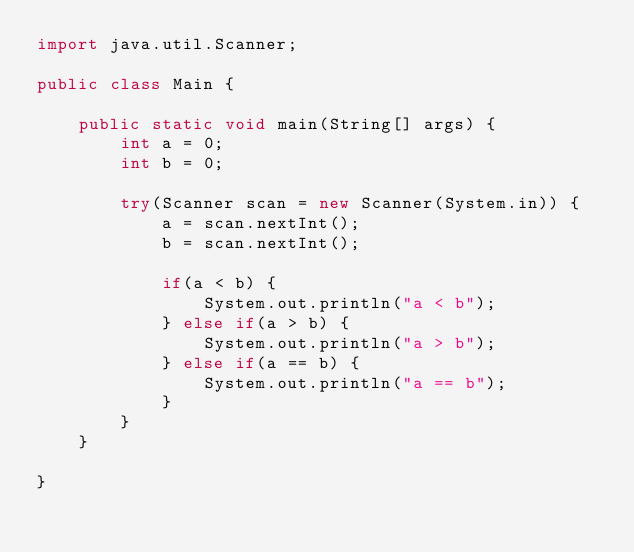Convert code to text. <code><loc_0><loc_0><loc_500><loc_500><_Java_>import java.util.Scanner;

public class Main {

	public static void main(String[] args) {
		int a = 0;
		int b = 0;

		try(Scanner scan = new Scanner(System.in)) {
			a = scan.nextInt();
			b = scan.nextInt();

			if(a < b) {
				System.out.println("a < b");
			} else if(a > b) {
				System.out.println("a > b");
			} else if(a == b) {
				System.out.println("a == b");
			}
		}
	}

}</code> 